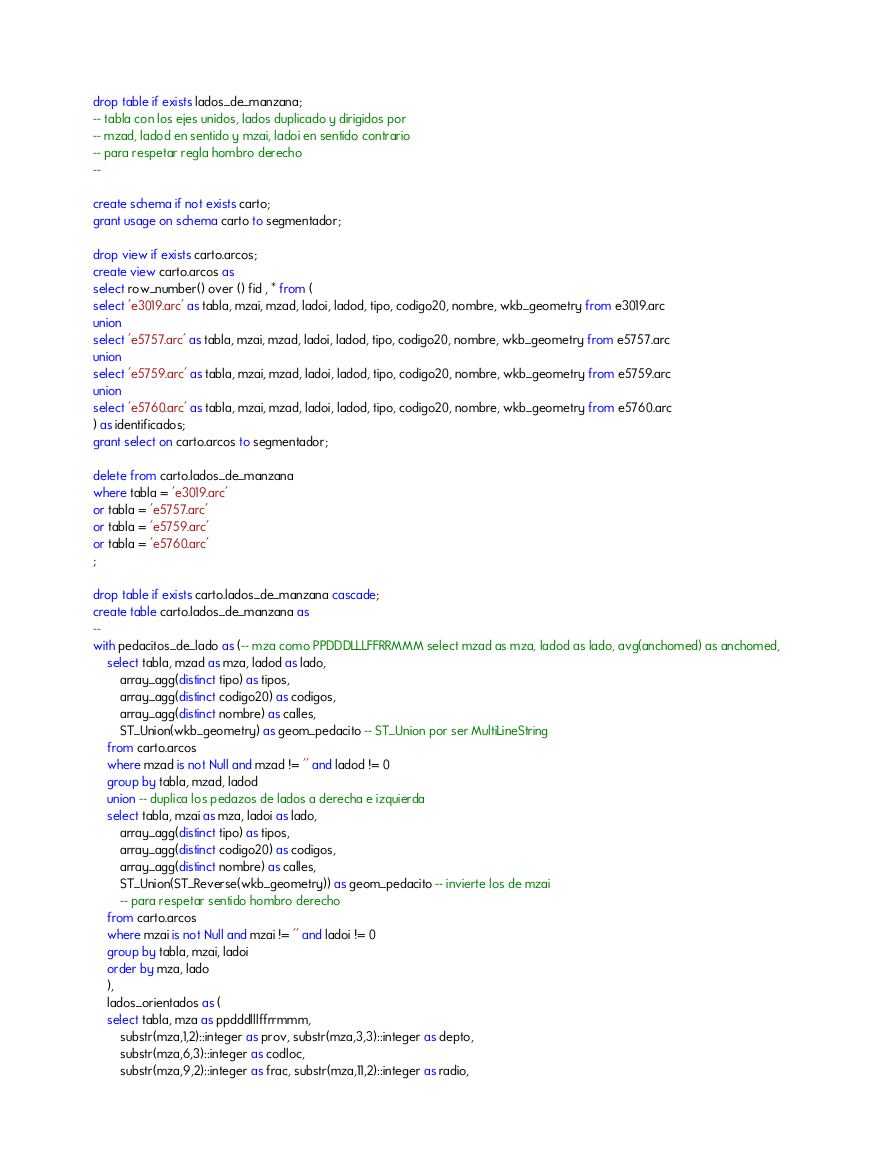<code> <loc_0><loc_0><loc_500><loc_500><_SQL_>drop table if exists lados_de_manzana;
-- tabla con los ejes unidos, lados duplicado y dirigidos por
-- mzad, ladod en sentido y mzai, ladoi en sentido contrario
-- para respetar regla hombro derecho
--

create schema if not exists carto;
grant usage on schema carto to segmentador;

drop view if exists carto.arcos;
create view carto.arcos as
select row_number() over () fid , * from (
select 'e3019.arc' as tabla, mzai, mzad, ladoi, ladod, tipo, codigo20, nombre, wkb_geometry from e3019.arc
union
select 'e5757.arc' as tabla, mzai, mzad, ladoi, ladod, tipo, codigo20, nombre, wkb_geometry from e5757.arc
union
select 'e5759.arc' as tabla, mzai, mzad, ladoi, ladod, tipo, codigo20, nombre, wkb_geometry from e5759.arc
union
select 'e5760.arc' as tabla, mzai, mzad, ladoi, ladod, tipo, codigo20, nombre, wkb_geometry from e5760.arc
) as identificados;
grant select on carto.arcos to segmentador;

delete from carto.lados_de_manzana
where tabla = 'e3019.arc'
or tabla = 'e5757.arc'
or tabla = 'e5759.arc'
or tabla = 'e5760.arc'
;

drop table if exists carto.lados_de_manzana cascade;
create table carto.lados_de_manzana as
--
with pedacitos_de_lado as (-- mza como PPDDDLLLFFRRMMM select mzad as mza, ladod as lado, avg(anchomed) as anchomed,
    select tabla, mzad as mza, ladod as lado,
        array_agg(distinct tipo) as tipos,
        array_agg(distinct codigo20) as codigos,
        array_agg(distinct nombre) as calles,
        ST_Union(wkb_geometry) as geom_pedacito -- ST_Union por ser MultiLineString
    from carto.arcos
    where mzad is not Null and mzad != '' and ladod != 0
    group by tabla, mzad, ladod
    union -- duplica los pedazos de lados a derecha e izquierda
    select tabla, mzai as mza, ladoi as lado,
        array_agg(distinct tipo) as tipos,
        array_agg(distinct codigo20) as codigos,
        array_agg(distinct nombre) as calles,
        ST_Union(ST_Reverse(wkb_geometry)) as geom_pedacito -- invierte los de mzai
        -- para respetar sentido hombro derecho
    from carto.arcos
    where mzai is not Null and mzai != '' and ladoi != 0
    group by tabla, mzai, ladoi
    order by mza, lado
    ),
    lados_orientados as (
    select tabla, mza as ppdddlllffrrmmm,
        substr(mza,1,2)::integer as prov, substr(mza,3,3)::integer as depto,
        substr(mza,6,3)::integer as codloc,
        substr(mza,9,2)::integer as frac, substr(mza,11,2)::integer as radio, </code> 